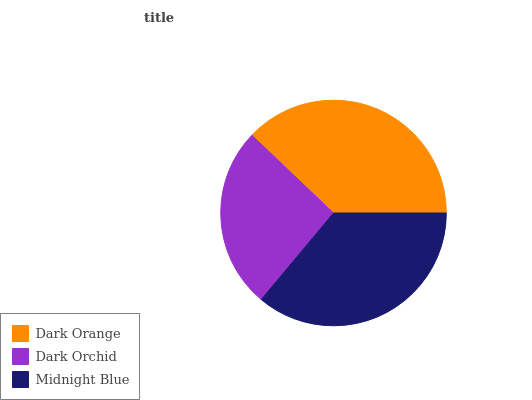Is Dark Orchid the minimum?
Answer yes or no. Yes. Is Dark Orange the maximum?
Answer yes or no. Yes. Is Midnight Blue the minimum?
Answer yes or no. No. Is Midnight Blue the maximum?
Answer yes or no. No. Is Midnight Blue greater than Dark Orchid?
Answer yes or no. Yes. Is Dark Orchid less than Midnight Blue?
Answer yes or no. Yes. Is Dark Orchid greater than Midnight Blue?
Answer yes or no. No. Is Midnight Blue less than Dark Orchid?
Answer yes or no. No. Is Midnight Blue the high median?
Answer yes or no. Yes. Is Midnight Blue the low median?
Answer yes or no. Yes. Is Dark Orange the high median?
Answer yes or no. No. Is Dark Orchid the low median?
Answer yes or no. No. 